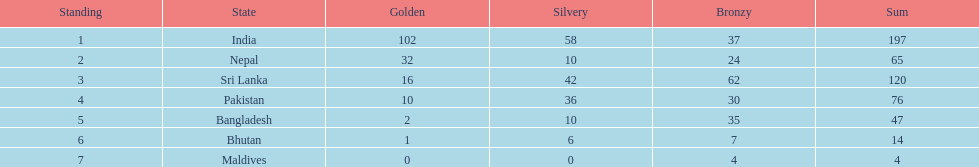Who has won the most bronze medals? Sri Lanka. 